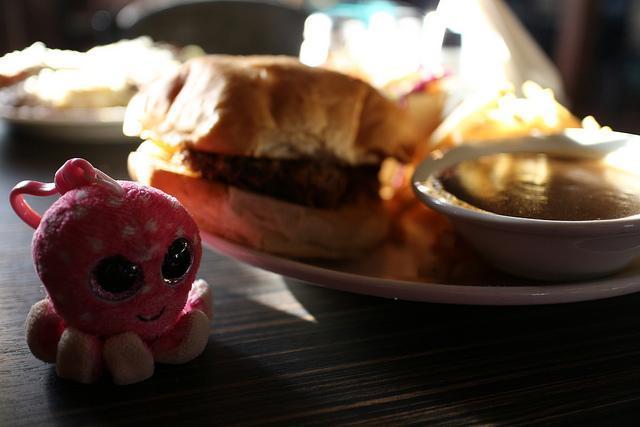How many sandwiches are in the photo?
Give a very brief answer. 2. How many sheep are there?
Give a very brief answer. 0. 